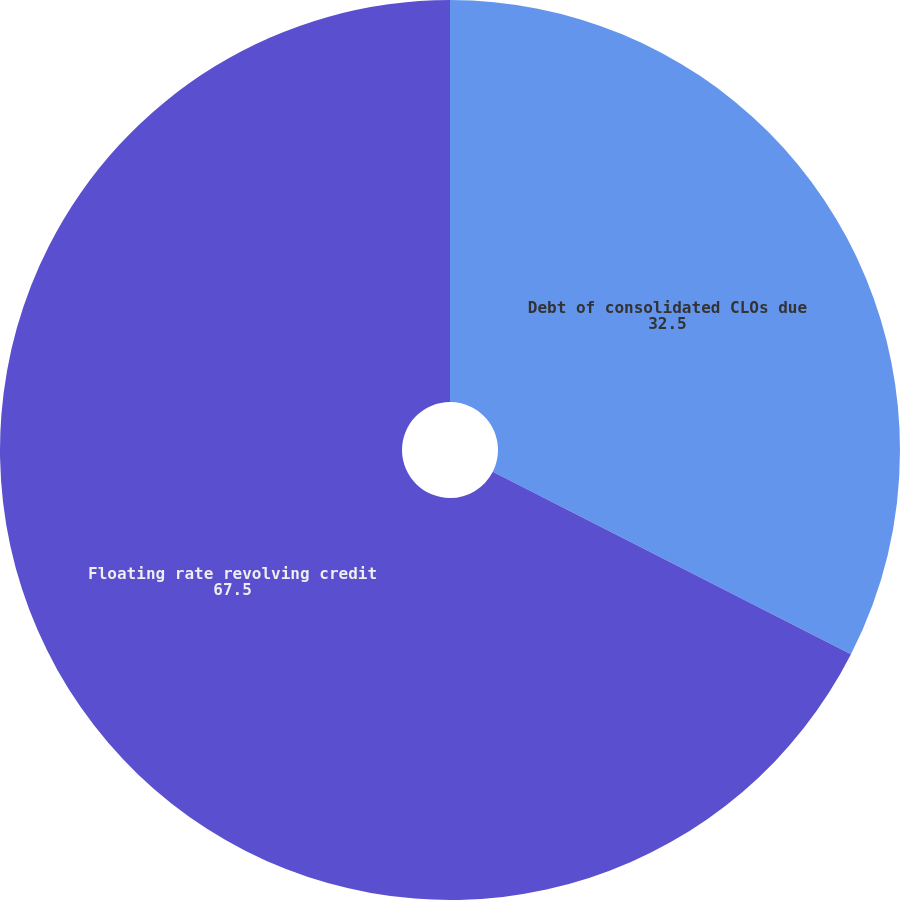Convert chart to OTSL. <chart><loc_0><loc_0><loc_500><loc_500><pie_chart><fcel>Debt of consolidated CLOs due<fcel>Floating rate revolving credit<nl><fcel>32.5%<fcel>67.5%<nl></chart> 